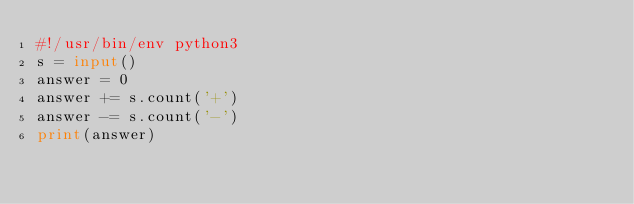<code> <loc_0><loc_0><loc_500><loc_500><_Python_>#!/usr/bin/env python3
s = input()
answer = 0
answer += s.count('+')
answer -= s.count('-')
print(answer)
</code> 